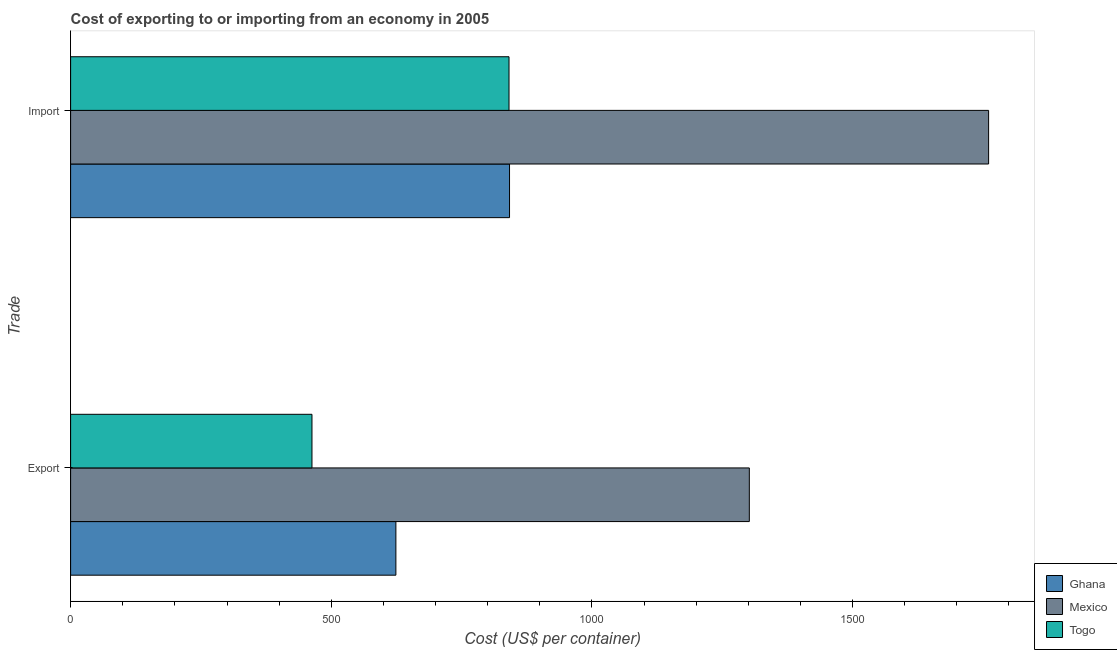How many different coloured bars are there?
Your answer should be very brief. 3. How many groups of bars are there?
Give a very brief answer. 2. How many bars are there on the 1st tick from the top?
Ensure brevity in your answer.  3. How many bars are there on the 1st tick from the bottom?
Ensure brevity in your answer.  3. What is the label of the 1st group of bars from the top?
Keep it short and to the point. Import. What is the import cost in Togo?
Your answer should be very brief. 841. Across all countries, what is the maximum import cost?
Your answer should be very brief. 1761. Across all countries, what is the minimum import cost?
Your response must be concise. 841. In which country was the import cost minimum?
Your answer should be very brief. Togo. What is the total import cost in the graph?
Your answer should be compact. 3444. What is the difference between the export cost in Mexico and that in Ghana?
Your answer should be very brief. 678. What is the difference between the export cost in Togo and the import cost in Ghana?
Your answer should be very brief. -379. What is the average export cost per country?
Make the answer very short. 796.33. What is the difference between the import cost and export cost in Togo?
Offer a very short reply. 378. In how many countries, is the import cost greater than 1300 US$?
Your answer should be compact. 1. What is the ratio of the import cost in Mexico to that in Togo?
Your response must be concise. 2.09. What does the 3rd bar from the bottom in Import represents?
Keep it short and to the point. Togo. Are all the bars in the graph horizontal?
Your answer should be very brief. Yes. How many countries are there in the graph?
Provide a short and direct response. 3. Are the values on the major ticks of X-axis written in scientific E-notation?
Make the answer very short. No. Does the graph contain grids?
Give a very brief answer. No. How many legend labels are there?
Your answer should be very brief. 3. What is the title of the graph?
Your response must be concise. Cost of exporting to or importing from an economy in 2005. What is the label or title of the X-axis?
Offer a terse response. Cost (US$ per container). What is the label or title of the Y-axis?
Keep it short and to the point. Trade. What is the Cost (US$ per container) in Ghana in Export?
Ensure brevity in your answer.  624. What is the Cost (US$ per container) in Mexico in Export?
Your answer should be very brief. 1302. What is the Cost (US$ per container) of Togo in Export?
Your answer should be compact. 463. What is the Cost (US$ per container) of Ghana in Import?
Ensure brevity in your answer.  842. What is the Cost (US$ per container) of Mexico in Import?
Give a very brief answer. 1761. What is the Cost (US$ per container) of Togo in Import?
Offer a very short reply. 841. Across all Trade, what is the maximum Cost (US$ per container) of Ghana?
Offer a terse response. 842. Across all Trade, what is the maximum Cost (US$ per container) of Mexico?
Your answer should be very brief. 1761. Across all Trade, what is the maximum Cost (US$ per container) in Togo?
Provide a succinct answer. 841. Across all Trade, what is the minimum Cost (US$ per container) of Ghana?
Your answer should be very brief. 624. Across all Trade, what is the minimum Cost (US$ per container) of Mexico?
Provide a succinct answer. 1302. Across all Trade, what is the minimum Cost (US$ per container) of Togo?
Ensure brevity in your answer.  463. What is the total Cost (US$ per container) of Ghana in the graph?
Offer a terse response. 1466. What is the total Cost (US$ per container) of Mexico in the graph?
Offer a very short reply. 3063. What is the total Cost (US$ per container) of Togo in the graph?
Give a very brief answer. 1304. What is the difference between the Cost (US$ per container) of Ghana in Export and that in Import?
Provide a succinct answer. -218. What is the difference between the Cost (US$ per container) of Mexico in Export and that in Import?
Your answer should be compact. -459. What is the difference between the Cost (US$ per container) in Togo in Export and that in Import?
Offer a very short reply. -378. What is the difference between the Cost (US$ per container) of Ghana in Export and the Cost (US$ per container) of Mexico in Import?
Your response must be concise. -1137. What is the difference between the Cost (US$ per container) of Ghana in Export and the Cost (US$ per container) of Togo in Import?
Give a very brief answer. -217. What is the difference between the Cost (US$ per container) of Mexico in Export and the Cost (US$ per container) of Togo in Import?
Provide a succinct answer. 461. What is the average Cost (US$ per container) of Ghana per Trade?
Your answer should be compact. 733. What is the average Cost (US$ per container) of Mexico per Trade?
Give a very brief answer. 1531.5. What is the average Cost (US$ per container) of Togo per Trade?
Make the answer very short. 652. What is the difference between the Cost (US$ per container) of Ghana and Cost (US$ per container) of Mexico in Export?
Provide a succinct answer. -678. What is the difference between the Cost (US$ per container) in Ghana and Cost (US$ per container) in Togo in Export?
Make the answer very short. 161. What is the difference between the Cost (US$ per container) of Mexico and Cost (US$ per container) of Togo in Export?
Provide a short and direct response. 839. What is the difference between the Cost (US$ per container) in Ghana and Cost (US$ per container) in Mexico in Import?
Keep it short and to the point. -919. What is the difference between the Cost (US$ per container) in Ghana and Cost (US$ per container) in Togo in Import?
Your answer should be very brief. 1. What is the difference between the Cost (US$ per container) of Mexico and Cost (US$ per container) of Togo in Import?
Your answer should be very brief. 920. What is the ratio of the Cost (US$ per container) in Ghana in Export to that in Import?
Keep it short and to the point. 0.74. What is the ratio of the Cost (US$ per container) in Mexico in Export to that in Import?
Offer a very short reply. 0.74. What is the ratio of the Cost (US$ per container) of Togo in Export to that in Import?
Ensure brevity in your answer.  0.55. What is the difference between the highest and the second highest Cost (US$ per container) in Ghana?
Give a very brief answer. 218. What is the difference between the highest and the second highest Cost (US$ per container) in Mexico?
Provide a short and direct response. 459. What is the difference between the highest and the second highest Cost (US$ per container) in Togo?
Your answer should be compact. 378. What is the difference between the highest and the lowest Cost (US$ per container) in Ghana?
Your answer should be very brief. 218. What is the difference between the highest and the lowest Cost (US$ per container) of Mexico?
Offer a very short reply. 459. What is the difference between the highest and the lowest Cost (US$ per container) in Togo?
Make the answer very short. 378. 